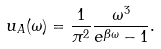<formula> <loc_0><loc_0><loc_500><loc_500>u _ { A } ( \omega ) = \frac { 1 } { \pi ^ { 2 } } \frac { \omega ^ { 3 } } { e ^ { \beta \omega } - 1 } .</formula> 